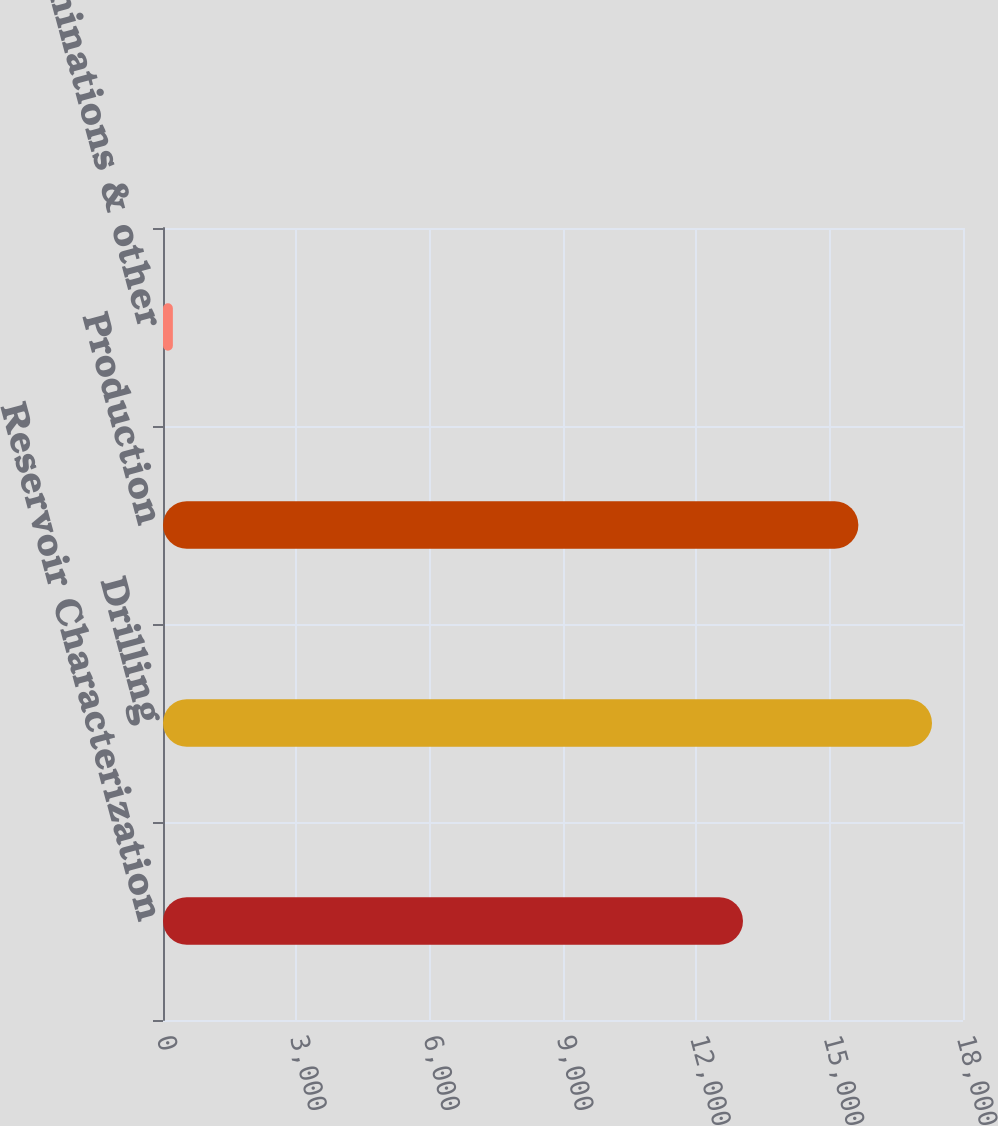Convert chart. <chart><loc_0><loc_0><loc_500><loc_500><bar_chart><fcel>Reservoir Characterization<fcel>Drilling<fcel>Production<fcel>Eliminations & other<nl><fcel>13050<fcel>17303<fcel>15646<fcel>222<nl></chart> 